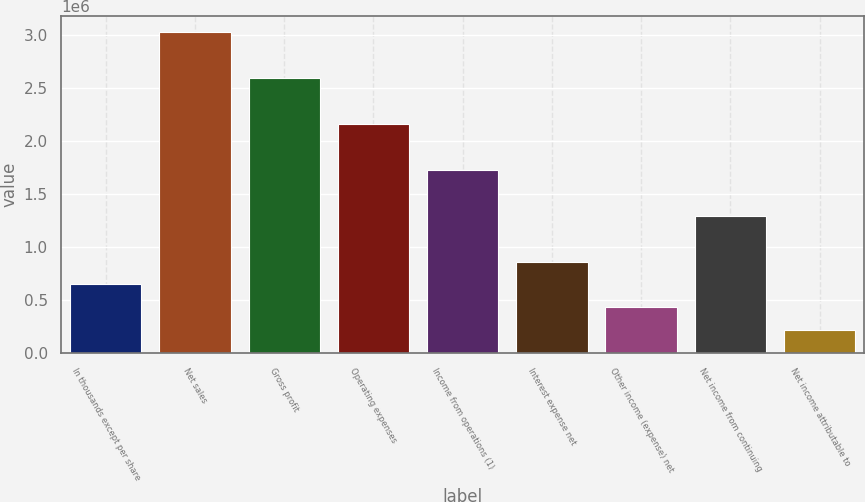Convert chart to OTSL. <chart><loc_0><loc_0><loc_500><loc_500><bar_chart><fcel>In thousands except per share<fcel>Net sales<fcel>Gross profit<fcel>Operating expenses<fcel>Income from operations (1)<fcel>Interest expense net<fcel>Other income (expense) net<fcel>Net income from continuing<fcel>Net income attributable to<nl><fcel>647686<fcel>3.02253e+06<fcel>2.59074e+06<fcel>2.15895e+06<fcel>1.72716e+06<fcel>863581<fcel>431791<fcel>1.29537e+06<fcel>215895<nl></chart> 